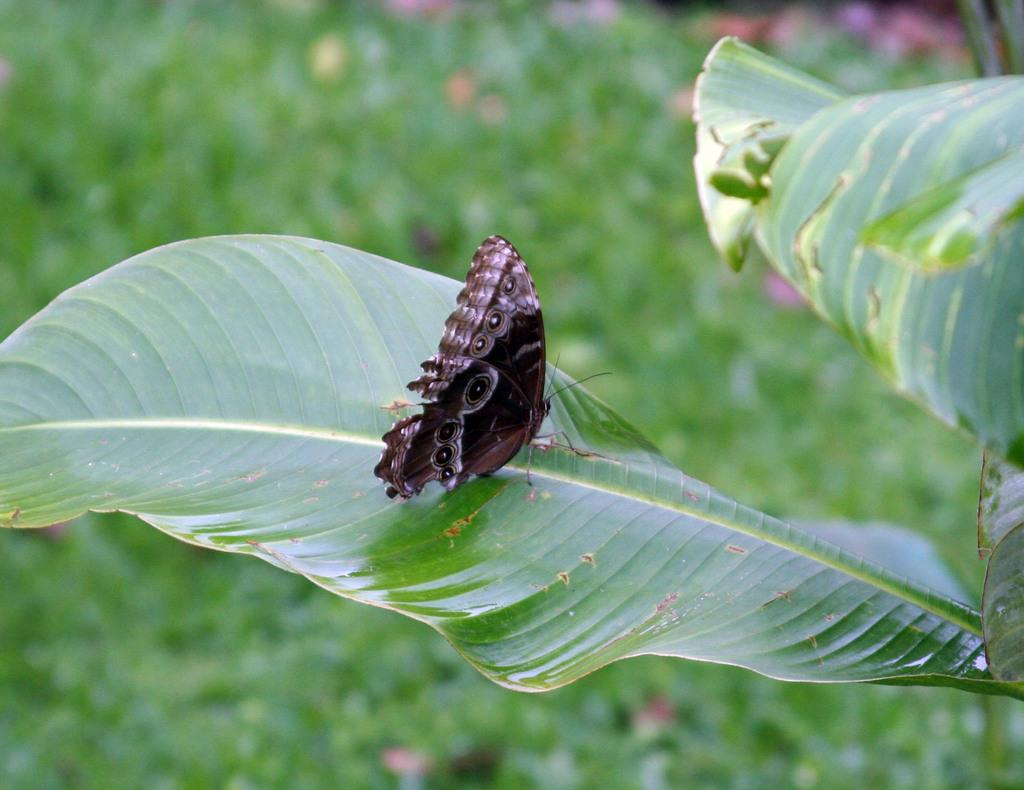What is the main subject of the image? There is a butterfly in the image. Can you describe the appearance of the butterfly? The butterfly is brown and white in color. Where is the butterfly located in the image? The butterfly is on a green leaf. What can be seen in the background of the image? There are plants visible in the background of the image. How are the plants positioned in the image? The plants are on the ground. What type of shoes is the butterfly wearing in the image? Butterflies do not wear shoes, so this question cannot be answered. 